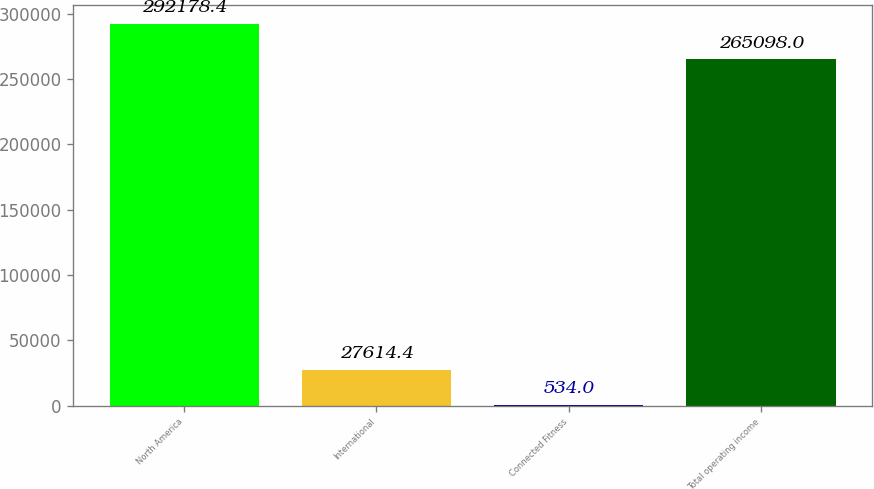<chart> <loc_0><loc_0><loc_500><loc_500><bar_chart><fcel>North America<fcel>International<fcel>Connected Fitness<fcel>Total operating income<nl><fcel>292178<fcel>27614.4<fcel>534<fcel>265098<nl></chart> 